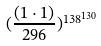<formula> <loc_0><loc_0><loc_500><loc_500>( \frac { ( 1 \cdot 1 ) } { 2 9 6 } ) ^ { 1 3 8 ^ { 1 3 0 } }</formula> 